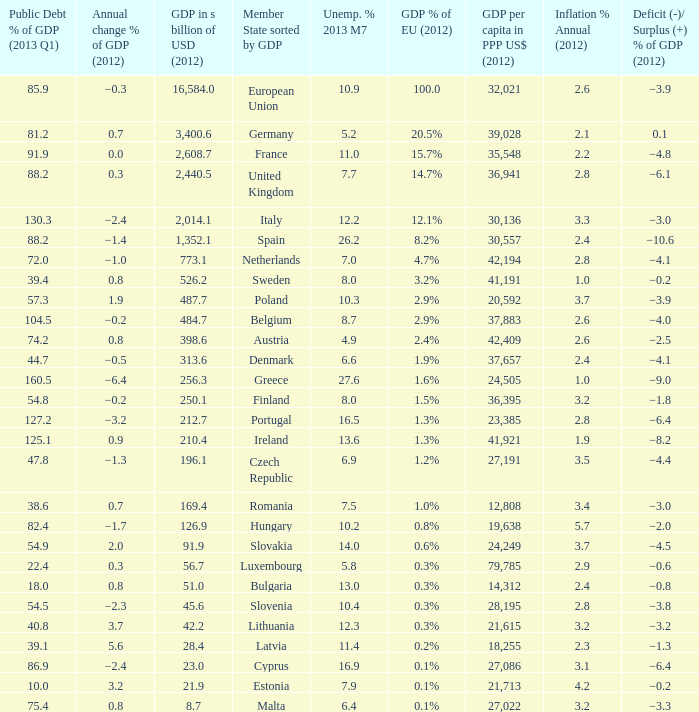3 billion usd? 1.6%. 